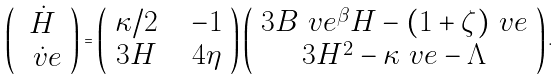Convert formula to latex. <formula><loc_0><loc_0><loc_500><loc_500>\left ( \begin{array} { c } \dot { H } \\ \dot { \ v e } \end{array} \right ) = \left ( \begin{array} { c c c } \kappa / 2 & & - 1 \\ 3 H & & 4 \eta \end{array} \right ) \left ( \begin{array} { c } 3 B \ v e ^ { \beta } H - ( 1 + \zeta ) \ v e \\ 3 H ^ { 2 } - \kappa \ v e - \Lambda \end{array} \right ) .</formula> 